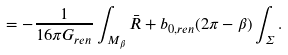<formula> <loc_0><loc_0><loc_500><loc_500>= - { \frac { 1 } { 1 6 \pi G _ { r e n } } } \int _ { M _ { \beta } } \bar { R } + b _ { 0 , r e n } ( 2 \pi - \beta ) \int _ { \Sigma } .</formula> 